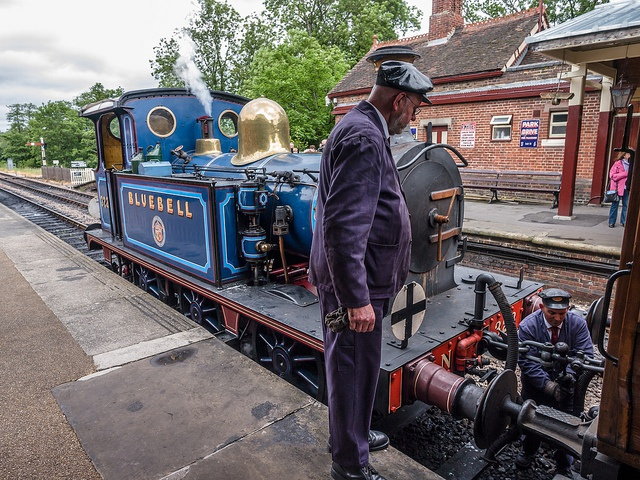Describe the objects in this image and their specific colors. I can see train in lightgray, black, gray, and darkgray tones, people in lightgray, black, and purple tones, people in lightgray, black, navy, purple, and gray tones, bench in lightgray, darkgray, gray, and black tones, and people in lightgray, violet, black, navy, and gray tones in this image. 